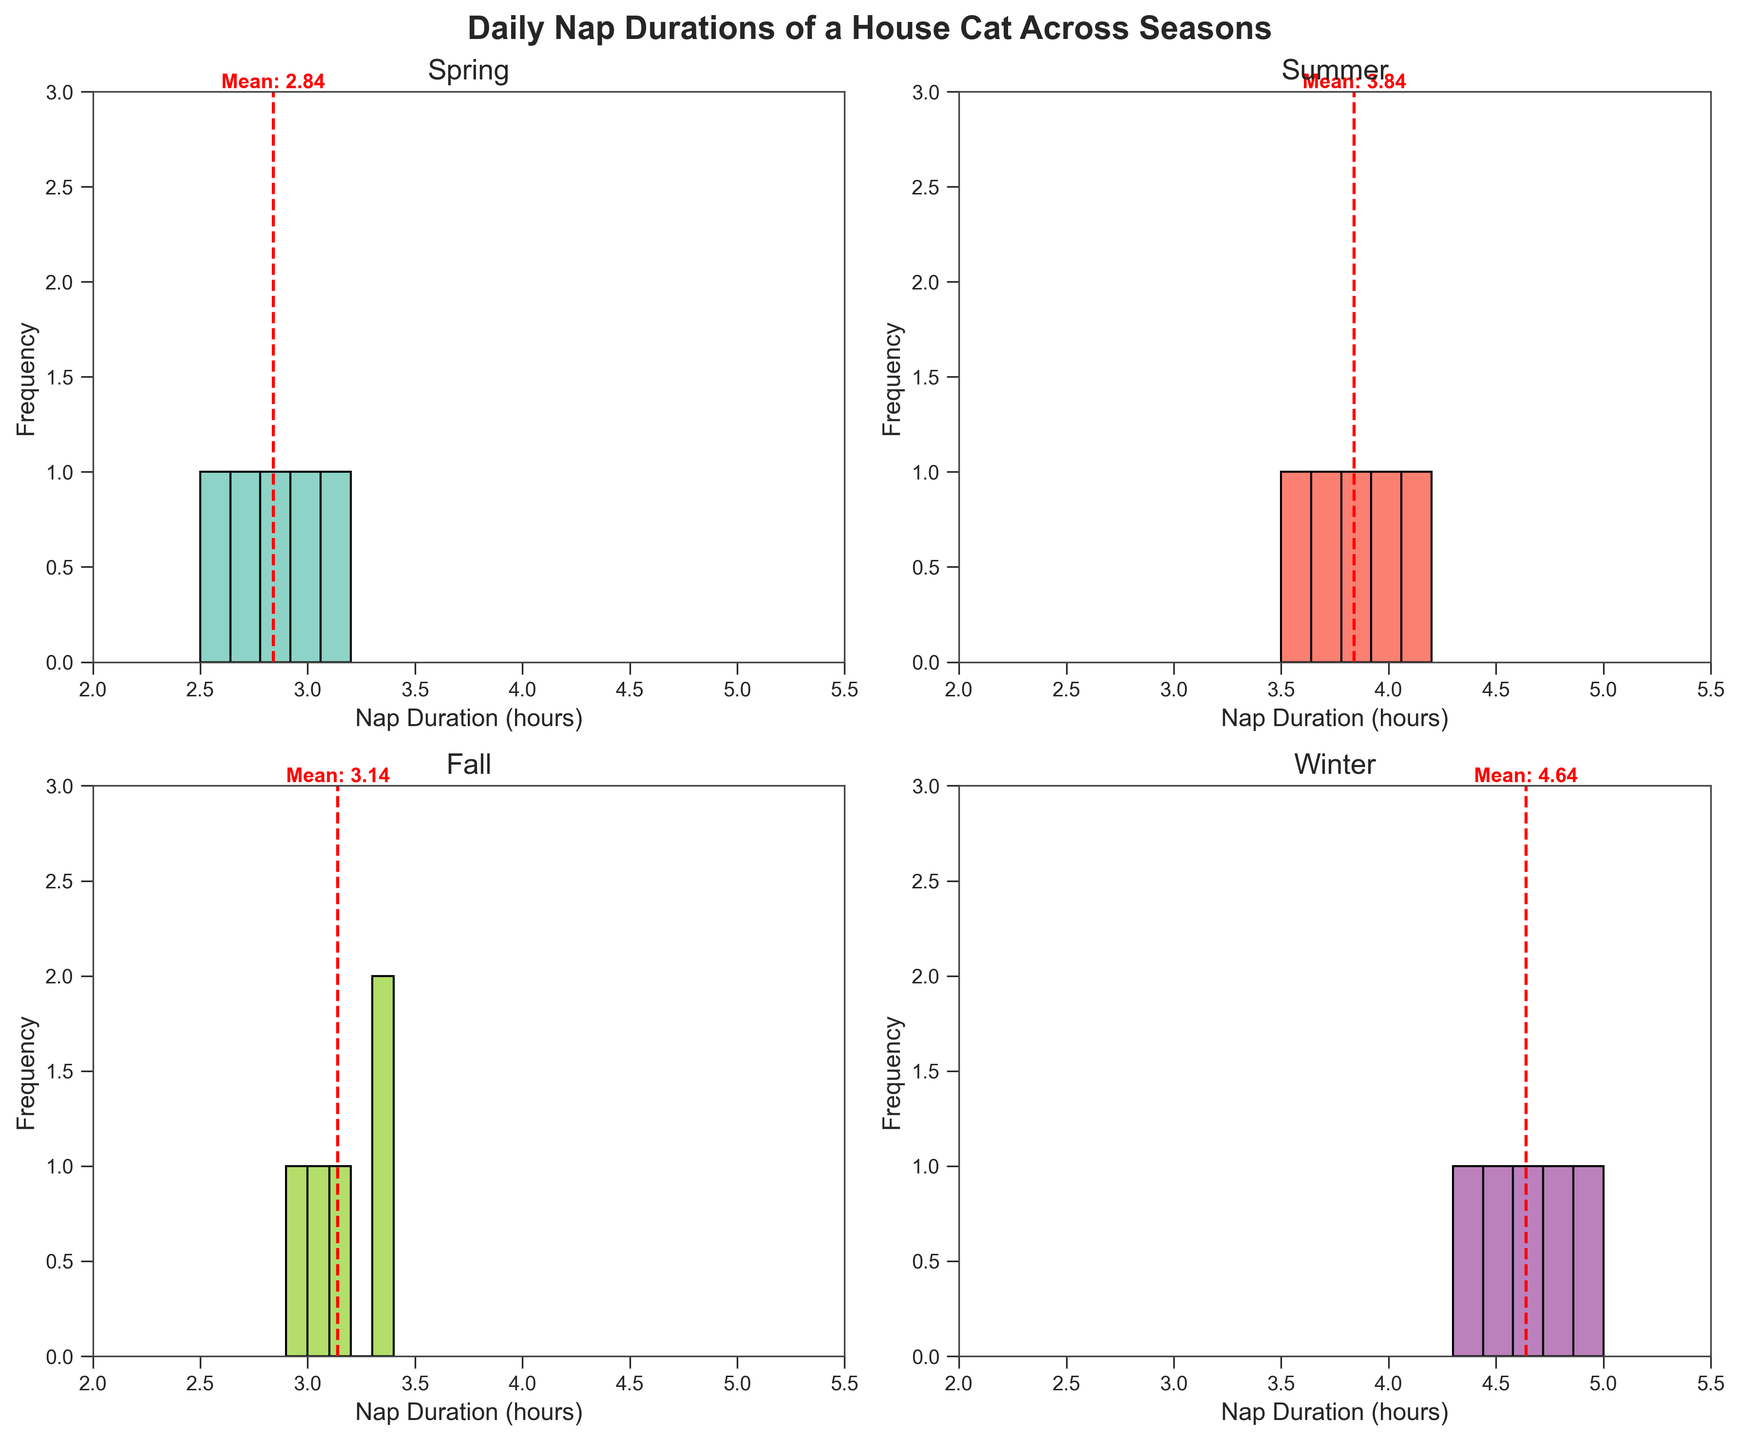What is the title of the figure? The title can be found at the top of the figure, which is 'Daily Nap Durations of a House Cat Across Seasons'.
Answer: 'Daily Nap Durations of a House Cat Across Seasons' How many nap duration data points are there for each season? You can count the number of bars in each subplot to determine the number of data points for each season. Each season has 5 bars.
Answer: 5 Which season shows the highest mean nap duration and what is the value? You can determine the highest mean by looking at the red dashed line indicating the mean in each subplot. The Winter subplot has the highest mean. The value is approximately 4.64 hours.
Answer: Winter, 4.64 hours What is the nap duration range shown on the x-axis for all subplots? The x-axis in all subplots shows the nap duration range from 2 to 5.5 hours.
Answer: 2 to 5.5 hours Which subplot shows the widest spread of nap durations and how can you tell? The wider spread can be identified by seeing the wider spread of bars along the x-axis. The Summer subplot shows the widest spread as the nap times range from 3.5 to 4.2 hours.
Answer: Summer What is the most frequent nap duration range in the Winter subplot? Identify the bar with the highest frequency. In the Winter subplot, the 4.5 to 5.0 hours range appears most frequently.
Answer: 4.5 to 5.0 hours Compare the mean nap durations for Spring and Summer. Which one is higher? Look at the red dashed lines for the means in the Spring and Summer subplots. The Summer subplot has a higher mean nap duration compared to Spring.
Answer: Summer What is the overall trend of nap durations from Spring to Winter? Review each subplot in sequence from Spring to Winter. The general trend is an increase in nap durations from Spring to Winter.
Answer: Increase How do the frequencies of nap durations in the Fall and Winter compare? Compare the height of the bars in the Fall and Winter subplots. Winter has higher frequencies for its nap durations compared to Fall.
Answer: Winter has higher frequencies Are there any nap durations in the range of 2.0 to 2.5 hours? If so, during which season(s)? Glance across all subplots for bars in the range of 2.0 to 2.5 hours. Only the Spring subplot includes nap durations in this range.
Answer: Spring 